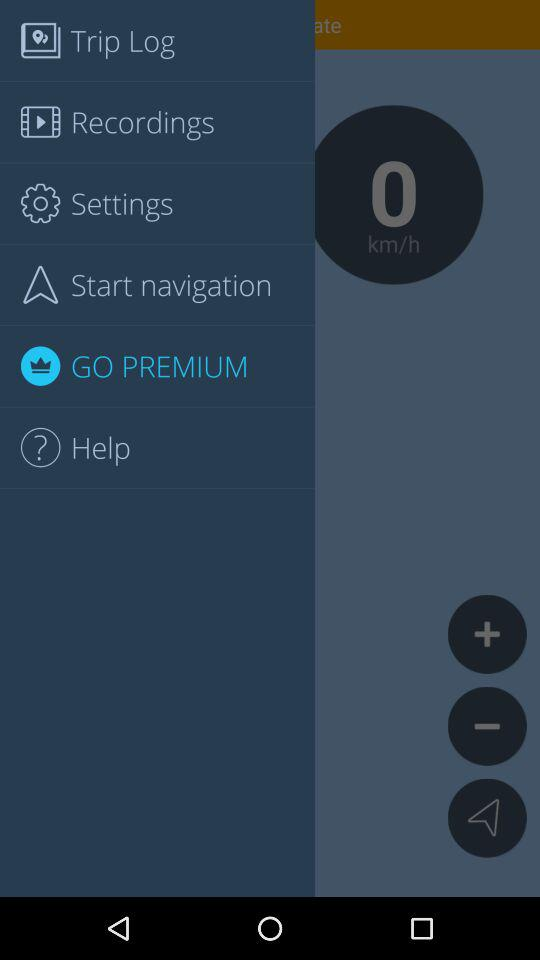How much does it cost to go premium?
When the provided information is insufficient, respond with <no answer>. <no answer> 